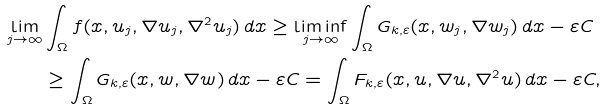Convert formula to latex. <formula><loc_0><loc_0><loc_500><loc_500>\lim _ { j \rightarrow \infty } & \int _ { \Omega } f ( x , u _ { j } , \nabla u _ { j } , \nabla ^ { 2 } u _ { j } ) \, d x \geq \liminf _ { j \rightarrow \infty } \int _ { \Omega } G _ { k , \varepsilon } ( x , w _ { j } , \nabla w _ { j } ) \, d x - \varepsilon C \\ & \geq \int _ { \Omega } G _ { k , \varepsilon } ( x , w , \nabla w ) \, d x - \varepsilon C = \int _ { \Omega } F _ { k , \varepsilon } ( x , u , \nabla u , \nabla ^ { 2 } u ) \, d x - \varepsilon C ,</formula> 